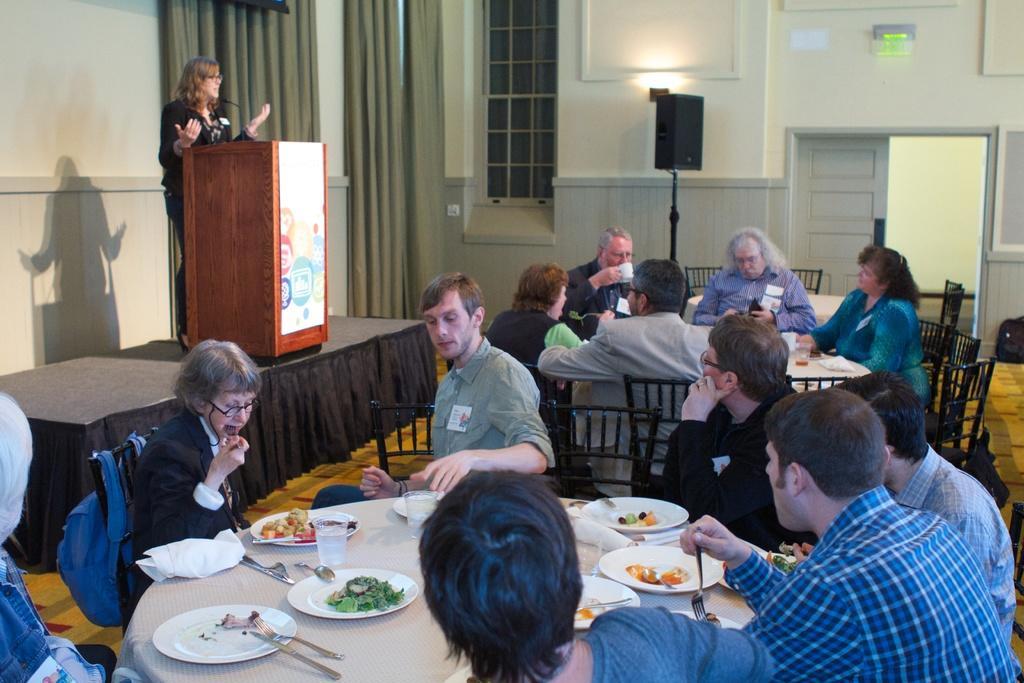Describe this image in one or two sentences. In the middle of the image a few people are sitting and dining. Behind them there is a speaker. In the middle of the image there is a door. Top right side of the image there is a wall. Top left side of the image a woman is standing and speaking on the microphone. Bottom left side of the image there is a table, On the table there is a plate, fork, spoon and glass. 